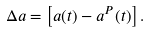Convert formula to latex. <formula><loc_0><loc_0><loc_500><loc_500>\Delta a = \left [ a ( t ) - a ^ { P } ( t ) \right ] .</formula> 